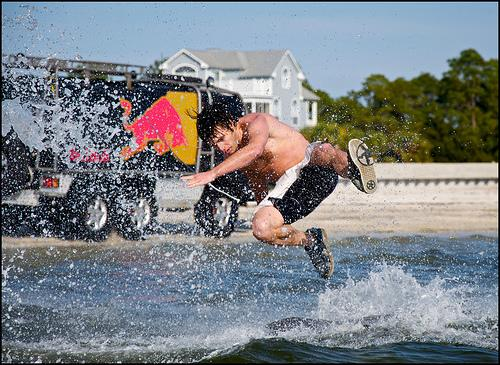Share a brief overview of the man's clothing and footwear in the image. The shirtless man is wearing black and white shorts along with black skate shoes with a tan sole. Describe the most notable vehicles present in the image. A black van with a red bull logo and a spare tire is near the water, with a silver ladder on its side. Express the actions and appearance of the person in the image in a poetic manner. A brave man with hair dark as night, leaps into the blue abyss, donning black and white garments while his feet hugged by ebony shoes. Mention the primary action performed by the person in the image. A man is jumping into the water creating a splash. What are some details about the body of water and its surroundings in the image? The water is blue and has white waves caused by the man's jump, with a sandy beach and green trees in the distance. Give a detailed account of the houses visible in the image. Large, gray houses are located by the water surrounded by trees, with a light blue two-story house being the most notable. Summarize what the person and the nearby vehicle in the image are doing. A man is jumping into the water, creating a splash, while a black van with a red bull logo is parked near the shoreline. Describe three distinct aspects of the image in three separate sentences. The man is performing a mid-air jump into the water. A black van with a red bull logo is parked nearby. Gray houses and green trees are present in the background. Narrate what the man is wearing and his appearance in the image. The man has wet, black hair and is shirtless, wearing black and white shorts and black sneakers with tan soles. Provide a description of the background scenery in the image. There are green trees, gray houses, and a black truck with a red bull logo near a small body of blue water. 